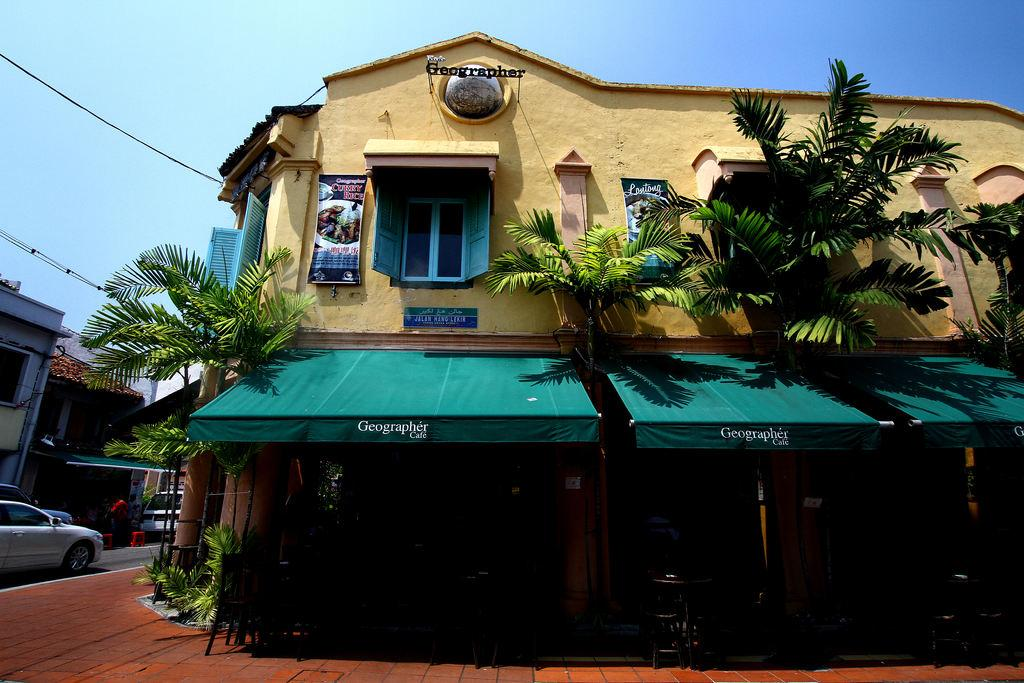What type of structure can be seen in the image? There is a building in the image. What other natural elements are present in the image? Trees are present in the image. What is the surface at the bottom of the image? There is a pavement at the bottom of the image. What mode of transportation can be seen on the left side of the image? A car is visible on the road on the left side of the image. What is visible at the top of the image? The sky is visible at the top of the image. How many lizards are crawling on the building in the image? There are no lizards present in the image; it only features a building, trees, pavement, a car, and the sky. 